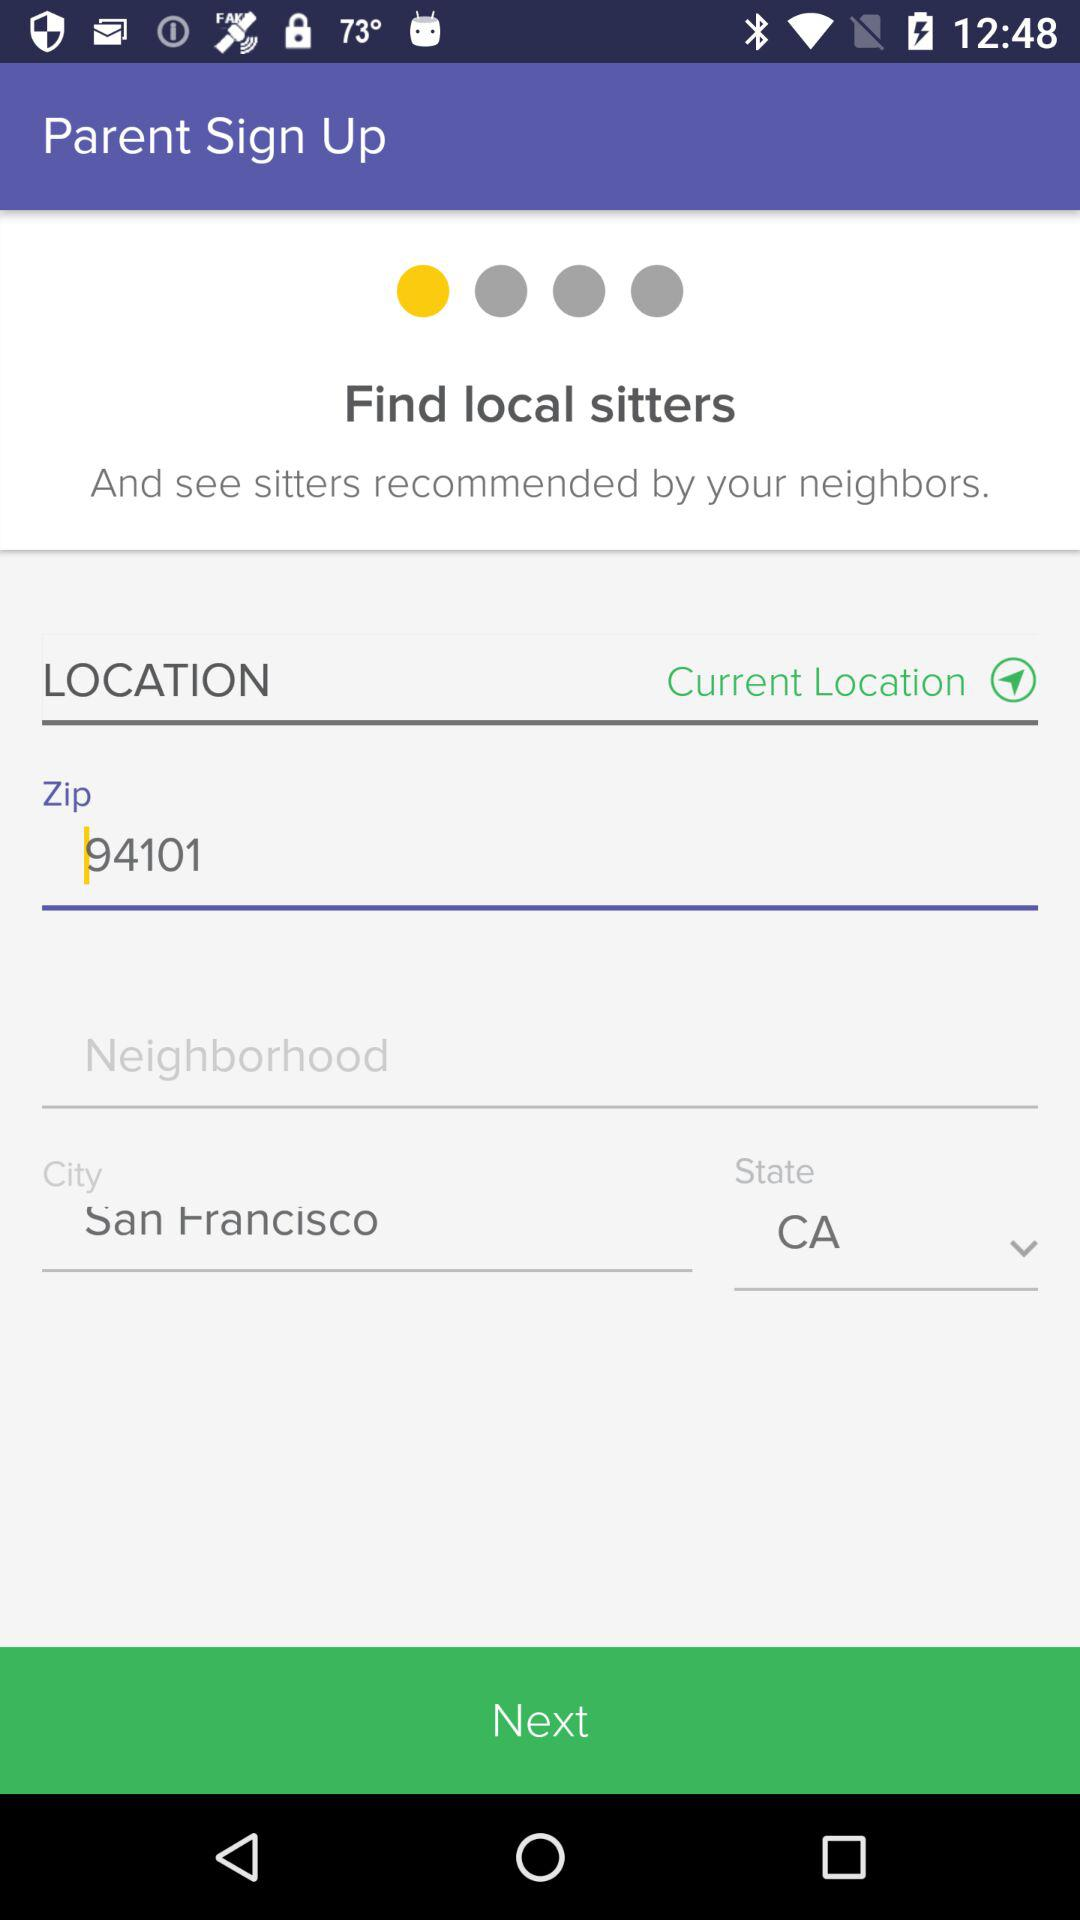Which state is given? The given state is California. 